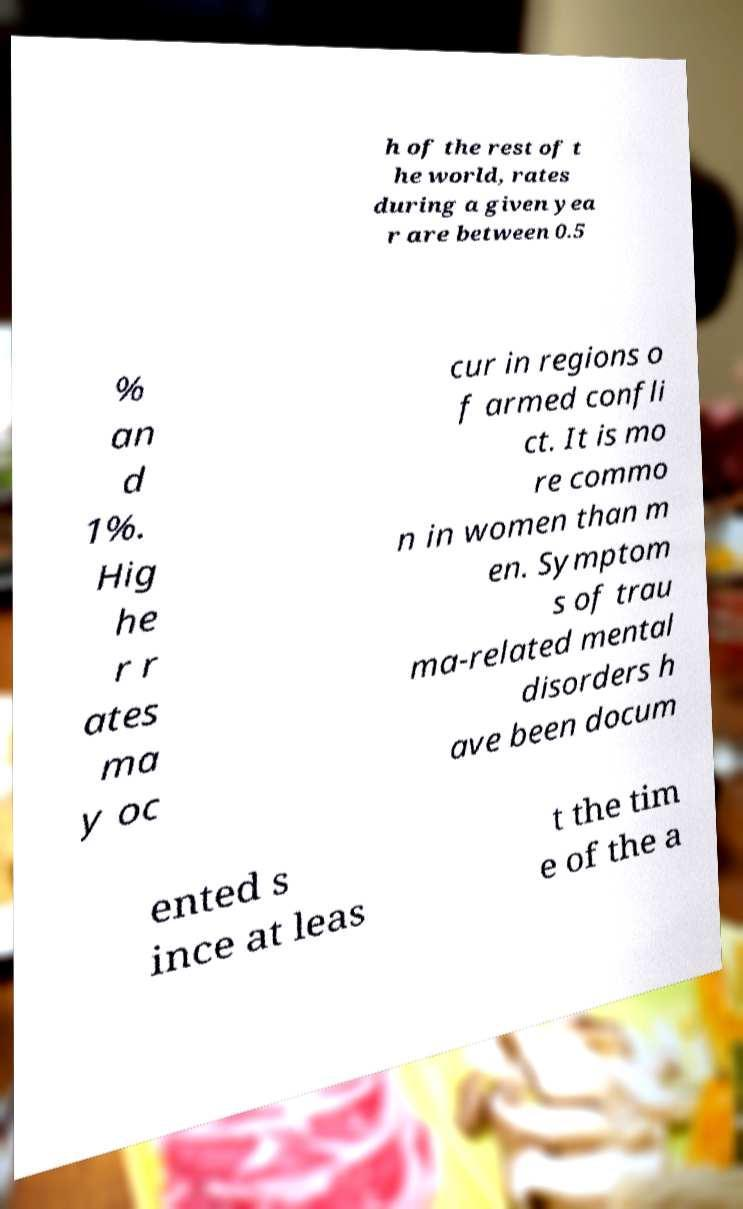Could you extract and type out the text from this image? h of the rest of t he world, rates during a given yea r are between 0.5 % an d 1%. Hig he r r ates ma y oc cur in regions o f armed confli ct. It is mo re commo n in women than m en. Symptom s of trau ma-related mental disorders h ave been docum ented s ince at leas t the tim e of the a 